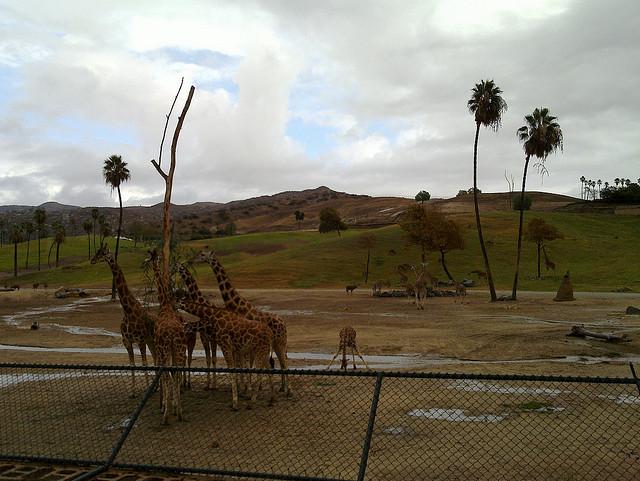Is this a natural wildlife preserve?
Write a very short answer. Yes. Is it sunny?
Be succinct. No. What are the tall trees called?
Give a very brief answer. Palm. 